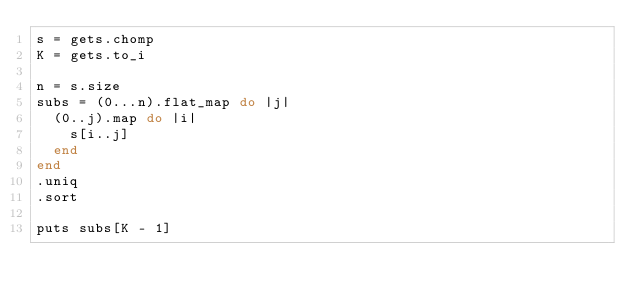<code> <loc_0><loc_0><loc_500><loc_500><_Ruby_>s = gets.chomp
K = gets.to_i

n = s.size
subs = (0...n).flat_map do |j|
  (0..j).map do |i|
    s[i..j]
  end
end
.uniq
.sort

puts subs[K - 1]
</code> 